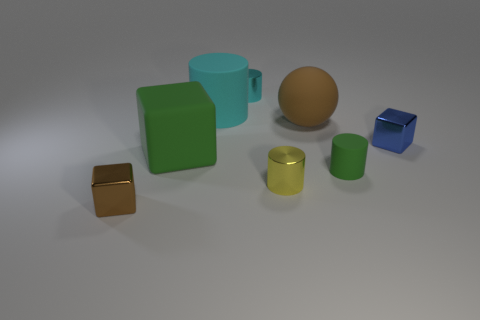What material does the large green object on the left appear to be made of? The large green object on the left presents a surface that appears to be made of a smooth, opaque plastic material. 